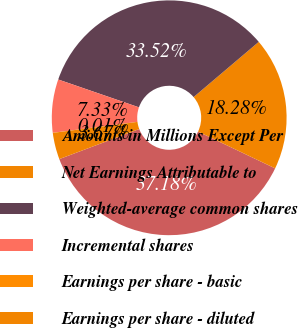Convert chart to OTSL. <chart><loc_0><loc_0><loc_500><loc_500><pie_chart><fcel>Amounts in Millions Except Per<fcel>Net Earnings Attributable to<fcel>Weighted-average common shares<fcel>Incremental shares<fcel>Earnings per share - basic<fcel>Earnings per share - diluted<nl><fcel>37.18%<fcel>18.28%<fcel>33.52%<fcel>7.33%<fcel>0.01%<fcel>3.67%<nl></chart> 